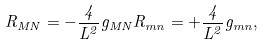Convert formula to latex. <formula><loc_0><loc_0><loc_500><loc_500>R _ { M N } = - \frac { 4 } { L ^ { 2 } } g _ { M N } R _ { m n } = + \frac { 4 } { L ^ { 2 } } g _ { m n } ,</formula> 